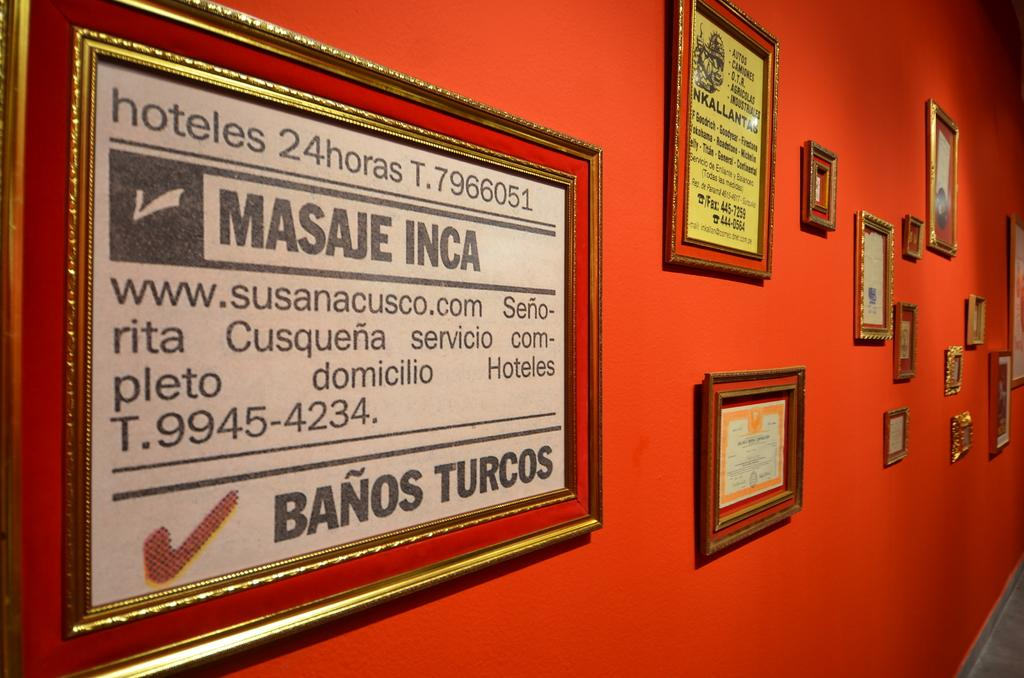<image>
Share a concise interpretation of the image provided. Photo framed on a wall that says Banos Turcos. 